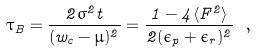Convert formula to latex. <formula><loc_0><loc_0><loc_500><loc_500>\tau _ { B } = \frac { 2 \sigma ^ { 2 } t } { ( w _ { c } - \mu ) ^ { 2 } } = \frac { 1 - 4 \langle F ^ { 2 } \rangle } { 2 ( \epsilon _ { p } + \epsilon _ { r } ) ^ { 2 } } \ ,</formula> 